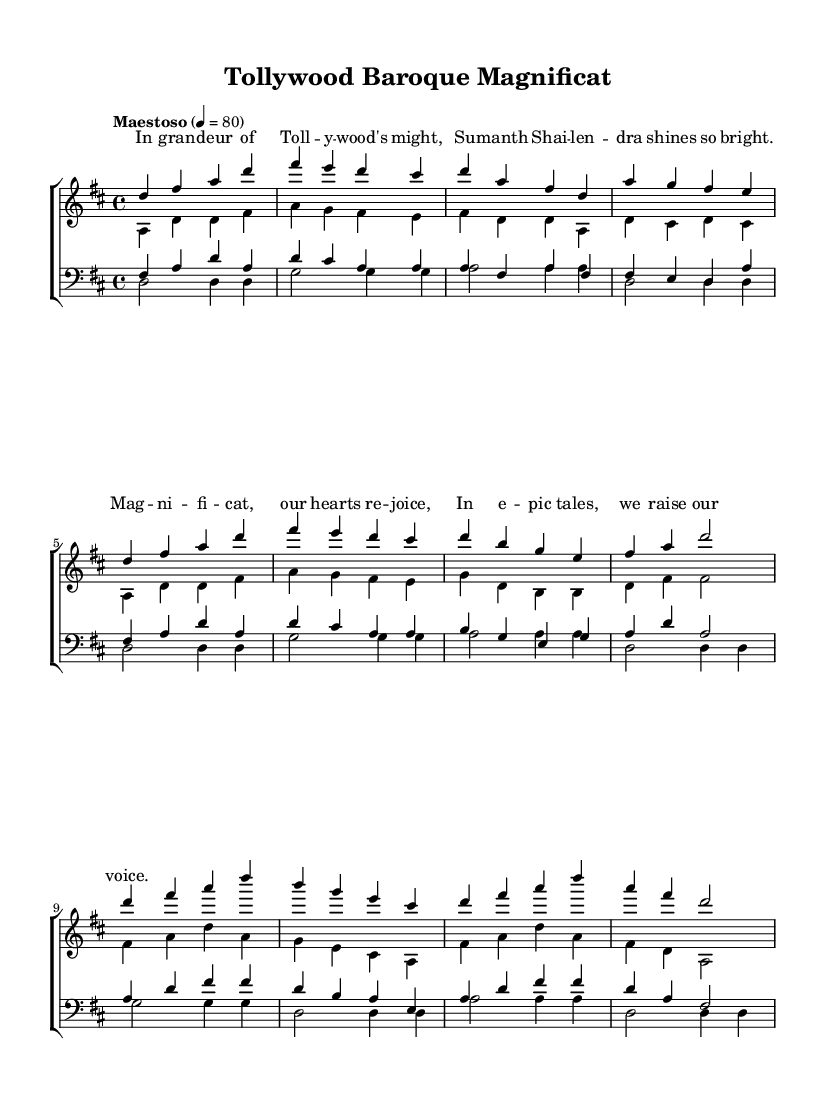What is the key signature of this music? The key signature shown in the score indicates D major, which has two sharps (F# and C#). This can be identified at the beginning of the staff, where the sharp symbols are placed.
Answer: D major What is the time signature of this music? The time signature displayed at the beginning of the score is 4/4, which indicates that there are four beats in each measure and the quarter note receives one beat. This is located right after the key signature.
Answer: 4/4 What is the tempo marking for this piece? The tempo marking "Maestoso" indicates a dignified and stately speed, and the numerical indication of 4 = 80 provides specific tempo guidance, meaning a quarter note should be played at 80 beats per minute. This can be found at the top of the score.
Answer: Maestoso, 80 How many voices are included in this choral work? The score features four distinct voices: soprano, alto, tenor, and bass. This is evident from the separate staves assigned for women (soprano and alto) and men (tenor and bass), which can be observed in the choir staff section of the score.
Answer: Four What text is sung during the chorus? The lyrics delivered during the chorus are, "In gran -- deur of Toll -- y -- wood's might, Su -- manth Shai -- len -- dra shines so bright." This can be found written underneath the soprano and alto staves in the lyrics section of the score.
Answer: In gran -- deur of Toll -- y -- wood's might, Su -- manth Shai -- len -- dra shines so bright Which voice part has the lowest range? The bass voice part has the lowest range, as indicated by its placement on the lowest staff and its lower note pitches compared to the other voice parts. The bass notes are written below the tenor, alto, and soprano lines in the score.
Answer: Bass How many measures are in the music provided? By counting the measures in each staff within the score, we can observe that there are a total of 24 measures present in the choral work. This includes all voice parts combined.
Answer: 24 